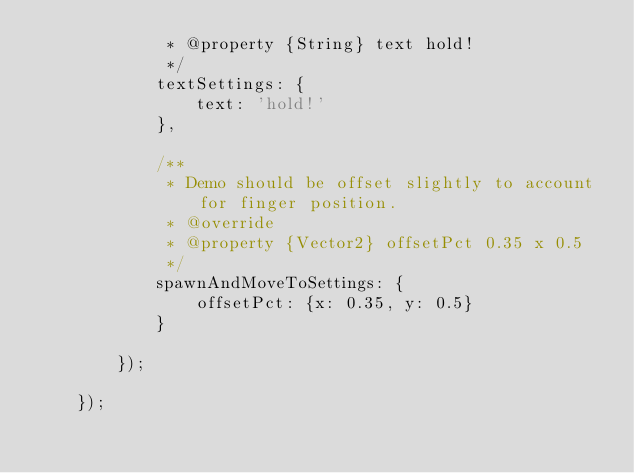Convert code to text. <code><loc_0><loc_0><loc_500><loc_500><_JavaScript_>             * @property {String} text hold!
             */
            textSettings: {
                text: 'hold!'
            },

            /**
             * Demo should be offset slightly to account for finger position.
             * @override
             * @property {Vector2} offsetPct 0.35 x 0.5
             */
            spawnAndMoveToSettings: {
                offsetPct: {x: 0.35, y: 0.5}
            }

        });

    });

</code> 